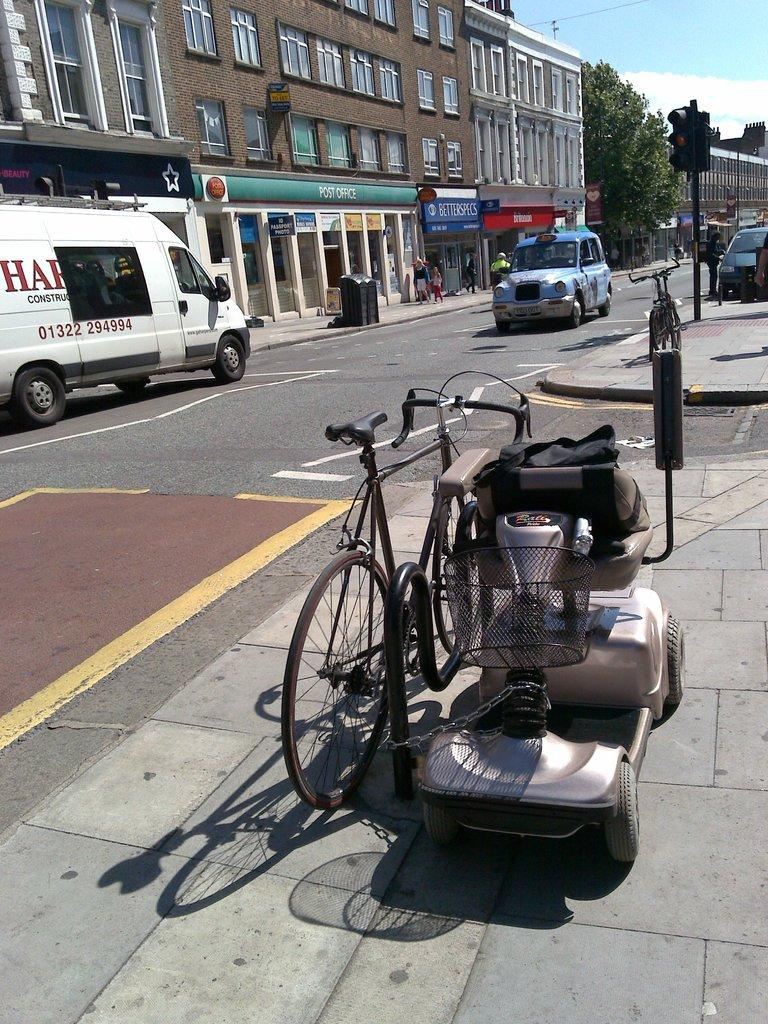Provide a one-sentence caption for the provided image. A bike is chained up to a wheel chair by a van that says construction. 